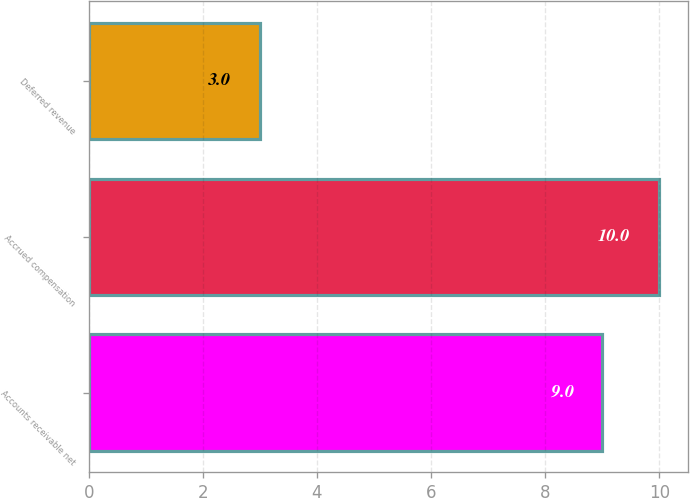Convert chart. <chart><loc_0><loc_0><loc_500><loc_500><bar_chart><fcel>Accounts receivable net<fcel>Accrued compensation<fcel>Deferred revenue<nl><fcel>9<fcel>10<fcel>3<nl></chart> 